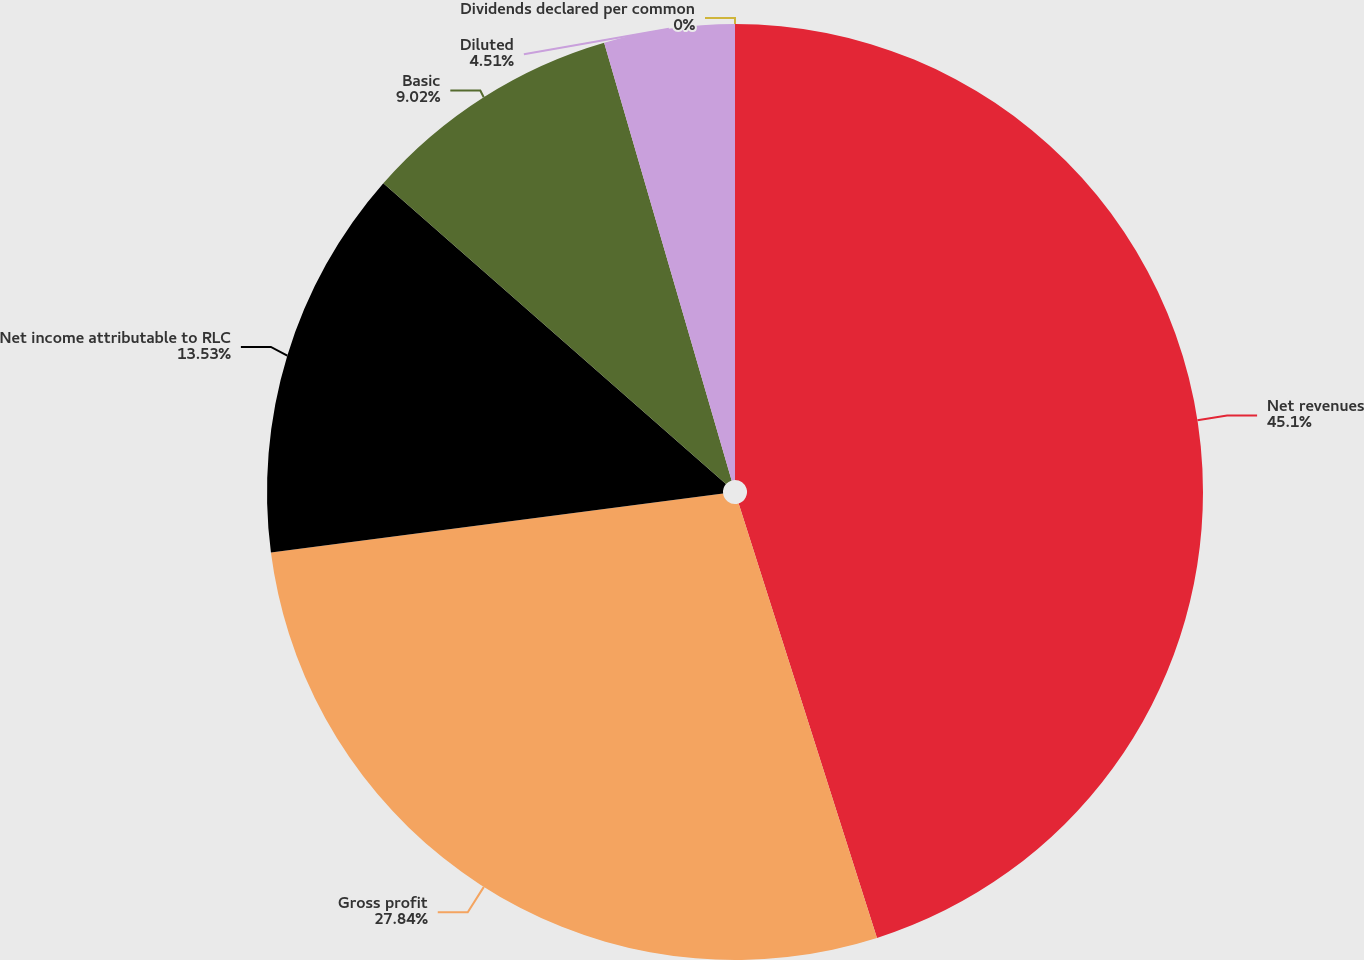Convert chart. <chart><loc_0><loc_0><loc_500><loc_500><pie_chart><fcel>Net revenues<fcel>Gross profit<fcel>Net income attributable to RLC<fcel>Basic<fcel>Diluted<fcel>Dividends declared per common<nl><fcel>45.09%<fcel>27.84%<fcel>13.53%<fcel>9.02%<fcel>4.51%<fcel>0.0%<nl></chart> 